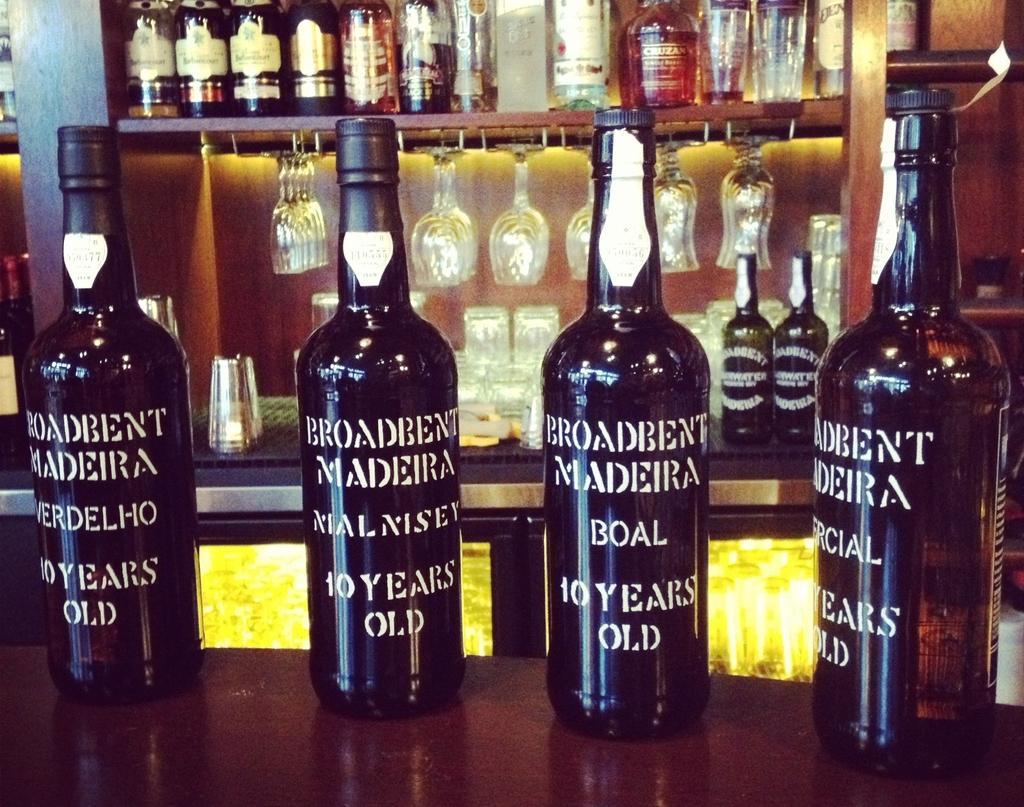<image>
Share a concise interpretation of the image provided. Four bottles of Madeira wine rest on the counter top. 